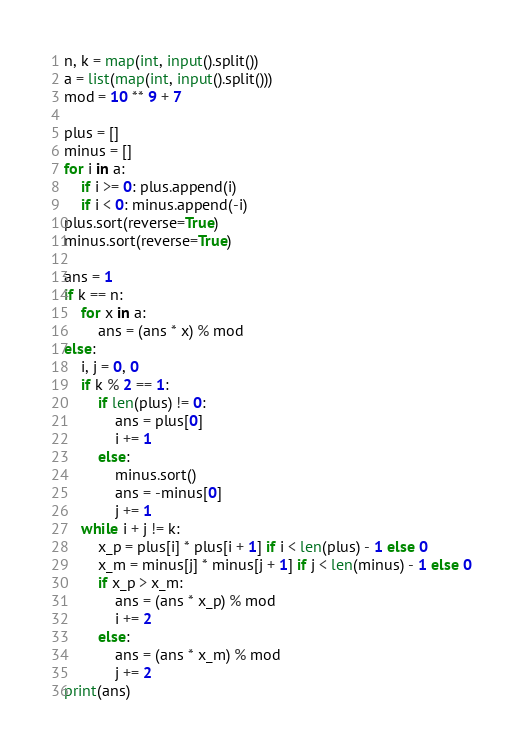<code> <loc_0><loc_0><loc_500><loc_500><_Python_>n, k = map(int, input().split())
a = list(map(int, input().split()))
mod = 10 ** 9 + 7

plus = []
minus = []
for i in a:
    if i >= 0: plus.append(i)
    if i < 0: minus.append(-i)
plus.sort(reverse=True)
minus.sort(reverse=True)

ans = 1
if k == n:
    for x in a:
        ans = (ans * x) % mod
else:
    i, j = 0, 0
    if k % 2 == 1:
        if len(plus) != 0:
            ans = plus[0]
            i += 1
        else:
            minus.sort()
            ans = -minus[0]
            j += 1
    while i + j != k:
        x_p = plus[i] * plus[i + 1] if i < len(plus) - 1 else 0
        x_m = minus[j] * minus[j + 1] if j < len(minus) - 1 else 0
        if x_p > x_m:
            ans = (ans * x_p) % mod
            i += 2
        else:
            ans = (ans * x_m) % mod
            j += 2
print(ans)
</code> 